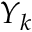Convert formula to latex. <formula><loc_0><loc_0><loc_500><loc_500>Y _ { k }</formula> 